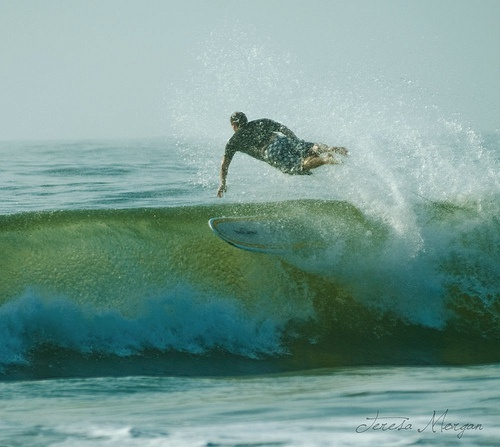Describe the objects in this image and their specific colors. I can see surfboard in lightblue and teal tones and people in lightblue, teal, darkgreen, and darkgray tones in this image. 